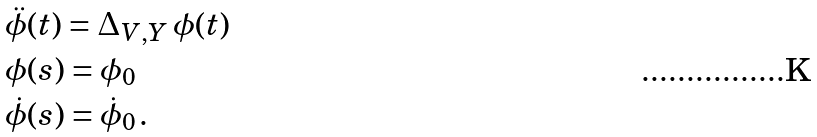<formula> <loc_0><loc_0><loc_500><loc_500>& \ddot { \phi } ( t ) = \Delta _ { V , Y } \, \phi ( t ) \\ & \phi ( s ) = \phi _ { 0 } \\ & \dot { \phi } ( s ) = \dot { \phi } _ { 0 } \, .</formula> 